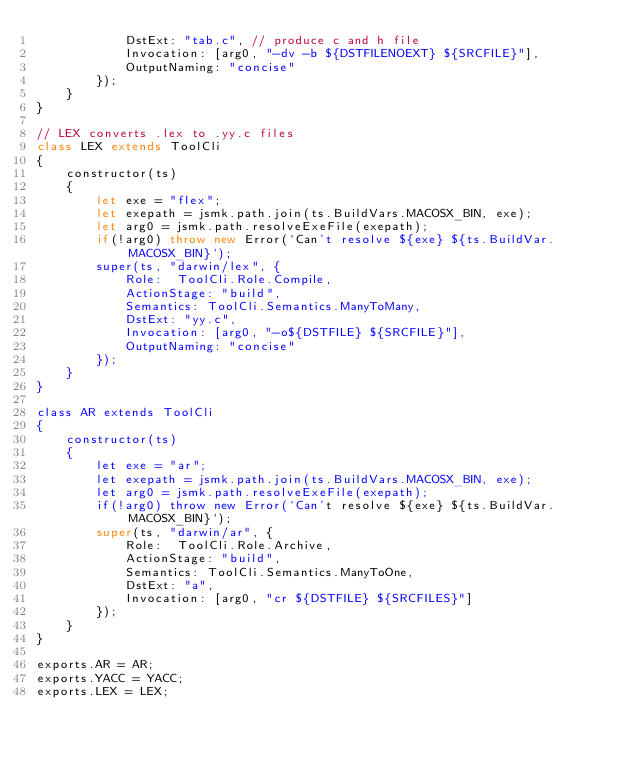<code> <loc_0><loc_0><loc_500><loc_500><_JavaScript_>            DstExt: "tab.c", // produce c and h file
            Invocation: [arg0, "-dv -b ${DSTFILENOEXT} ${SRCFILE}"],
            OutputNaming: "concise"
        });
    }
}

// LEX converts .lex to .yy.c files
class LEX extends ToolCli
{
    constructor(ts)
    {
        let exe = "flex";
        let exepath = jsmk.path.join(ts.BuildVars.MACOSX_BIN, exe);
        let arg0 = jsmk.path.resolveExeFile(exepath);
        if(!arg0) throw new Error(`Can't resolve ${exe} ${ts.BuildVar.MACOSX_BIN}`);
        super(ts, "darwin/lex", {
            Role:  ToolCli.Role.Compile,
            ActionStage: "build",
            Semantics: ToolCli.Semantics.ManyToMany,
            DstExt: "yy.c",
            Invocation: [arg0, "-o${DSTFILE} ${SRCFILE}"],
            OutputNaming: "concise"
        });
    }
}

class AR extends ToolCli
{
    constructor(ts)
    {
        let exe = "ar";
        let exepath = jsmk.path.join(ts.BuildVars.MACOSX_BIN, exe);
        let arg0 = jsmk.path.resolveExeFile(exepath);
        if(!arg0) throw new Error(`Can't resolve ${exe} ${ts.BuildVar.MACOSX_BIN}`);
        super(ts, "darwin/ar", {
            Role:  ToolCli.Role.Archive,
            ActionStage: "build",
            Semantics: ToolCli.Semantics.ManyToOne,
            DstExt: "a",
            Invocation: [arg0, "cr ${DSTFILE} ${SRCFILES}"]
        });
    }
}

exports.AR = AR;
exports.YACC = YACC;
exports.LEX = LEX;
</code> 